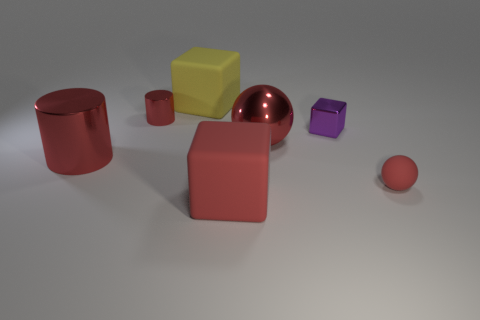Subtract all red balls. How many were subtracted if there are1red balls left? 1 Subtract all tiny purple blocks. How many blocks are left? 2 Add 1 tiny red cylinders. How many objects exist? 8 Subtract 1 spheres. How many spheres are left? 1 Add 3 matte cubes. How many matte cubes exist? 5 Subtract 1 yellow cubes. How many objects are left? 6 Subtract all spheres. How many objects are left? 5 Subtract all brown cubes. Subtract all green cylinders. How many cubes are left? 3 Subtract all red metallic cylinders. Subtract all small rubber objects. How many objects are left? 4 Add 5 matte balls. How many matte balls are left? 6 